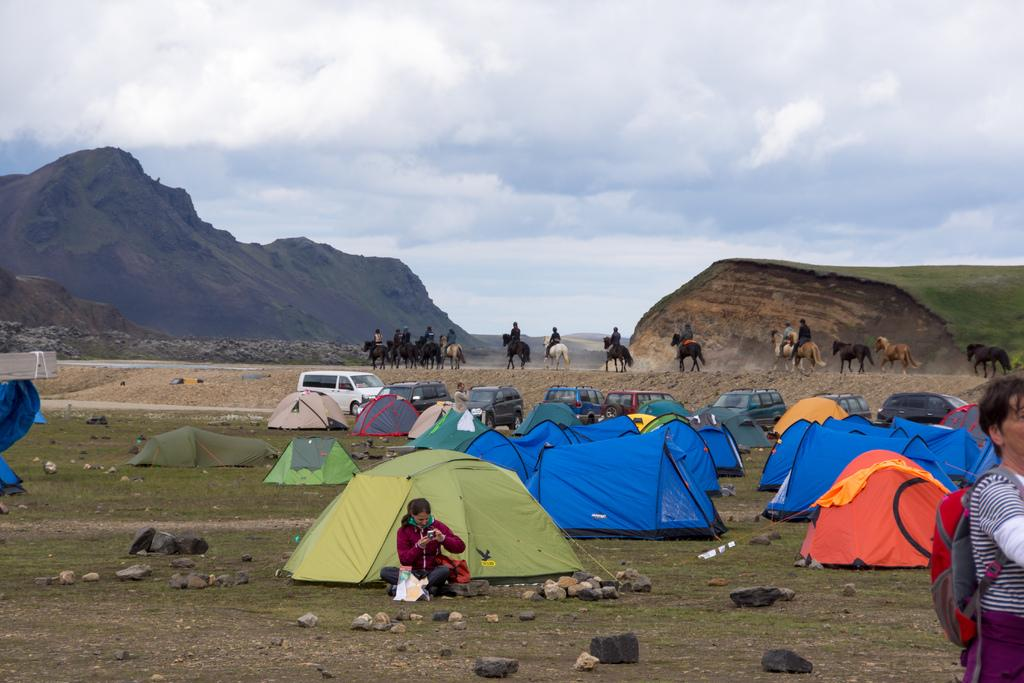What type of natural formation can be seen in the image? There are mountains in the image. What type of temporary shelter is visible in the image? There are camping-tents in the image. What material is present in the image? Stones are present in the image. Who is present in the image? There are people in the image. What are some people doing in the image? Some people are sitting on horses. What is the color of the sky in the image? The sky is blue and white in color. Where are the icicles hanging in the image? There are no icicles present in the image. What type of cloth is draped over the camping-tents in the image? There is no cloth draped over the camping-tents in the image; they are visible as they are. 